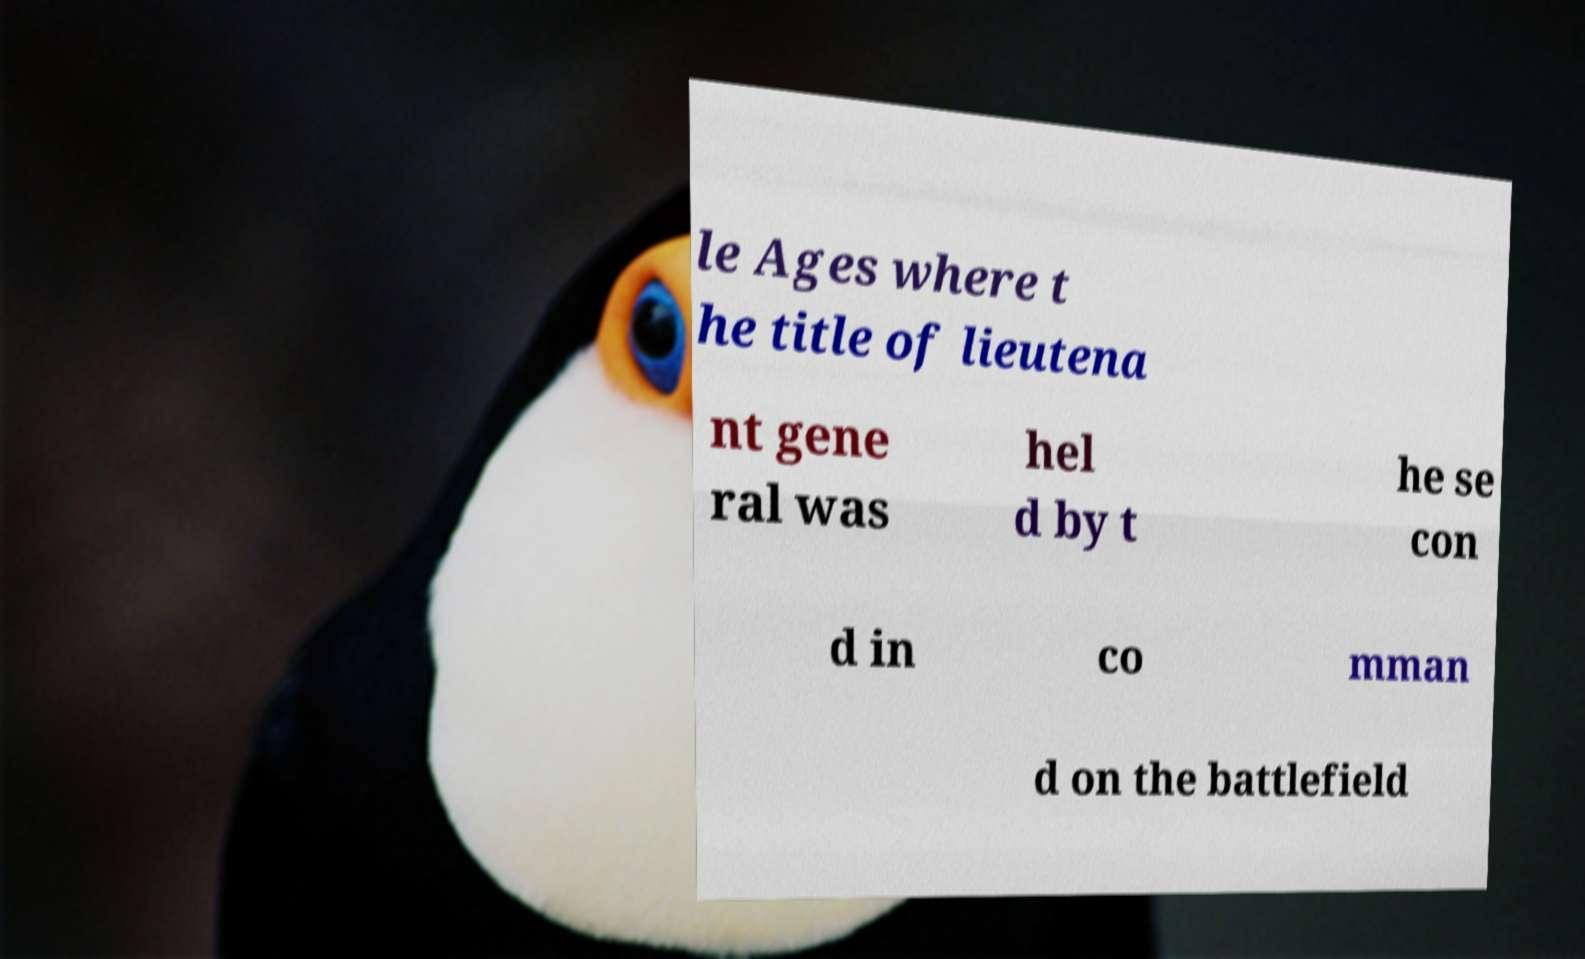For documentation purposes, I need the text within this image transcribed. Could you provide that? le Ages where t he title of lieutena nt gene ral was hel d by t he se con d in co mman d on the battlefield 